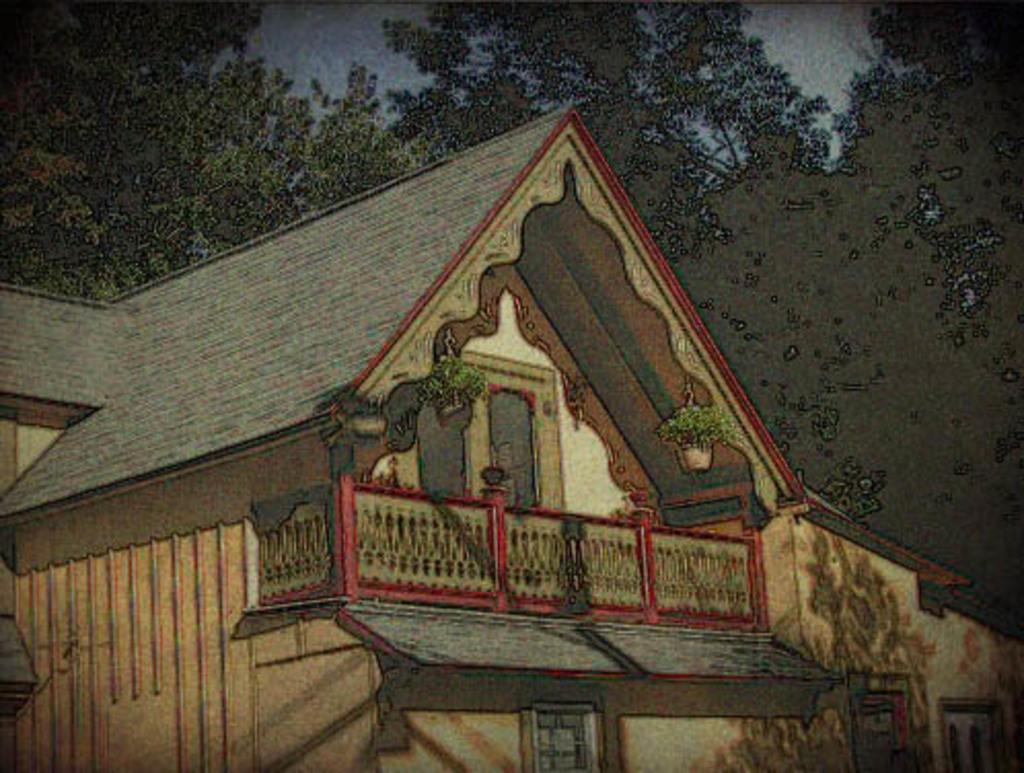Describe this image in one or two sentences. This is an edited image in which there is a house in the center and in the background there are trees. 